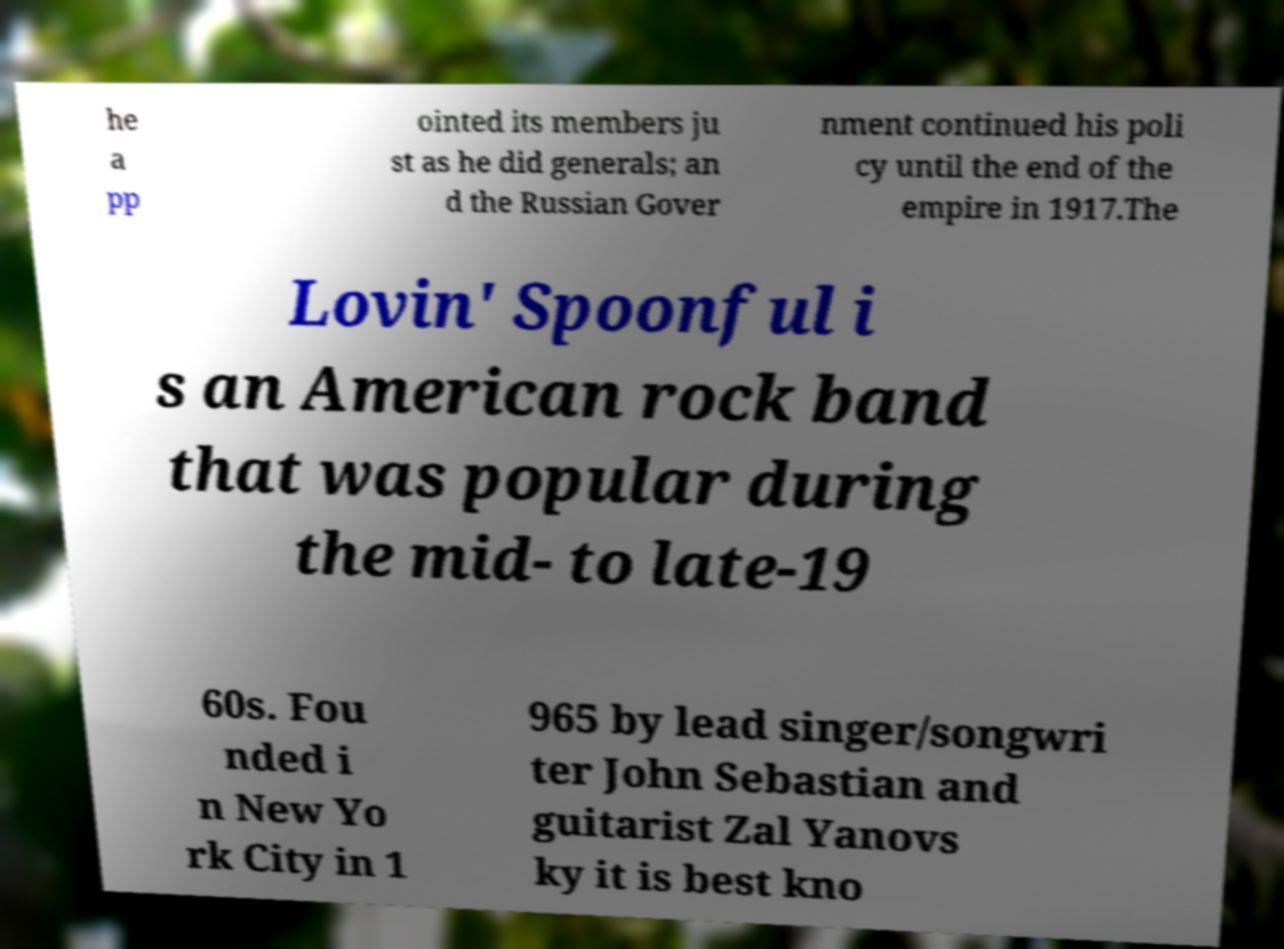What messages or text are displayed in this image? I need them in a readable, typed format. he a pp ointed its members ju st as he did generals; an d the Russian Gover nment continued his poli cy until the end of the empire in 1917.The Lovin' Spoonful i s an American rock band that was popular during the mid- to late-19 60s. Fou nded i n New Yo rk City in 1 965 by lead singer/songwri ter John Sebastian and guitarist Zal Yanovs ky it is best kno 